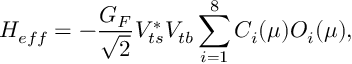<formula> <loc_0><loc_0><loc_500><loc_500>H _ { e f f } = - { \frac { G _ { F } } { \sqrt { 2 } } } V _ { t s } ^ { * } V _ { t b } \sum _ { i = 1 } ^ { 8 } C _ { i } ( \mu ) O _ { i } ( \mu ) ,</formula> 